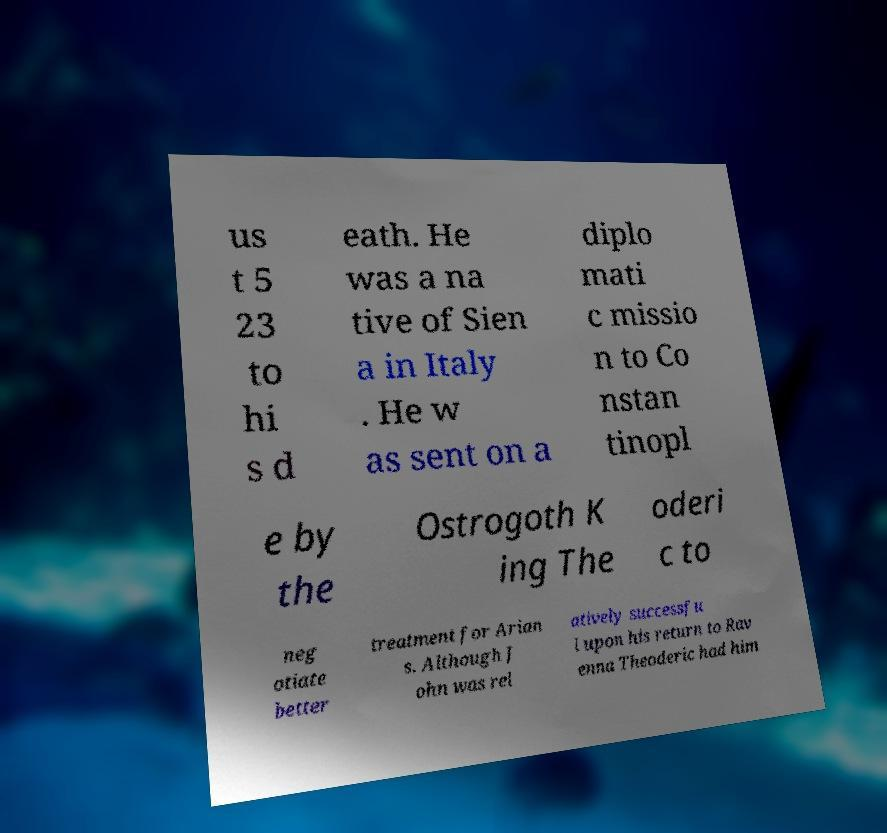For documentation purposes, I need the text within this image transcribed. Could you provide that? us t 5 23 to hi s d eath. He was a na tive of Sien a in Italy . He w as sent on a diplo mati c missio n to Co nstan tinopl e by the Ostrogoth K ing The oderi c to neg otiate better treatment for Arian s. Although J ohn was rel atively successfu l upon his return to Rav enna Theoderic had him 